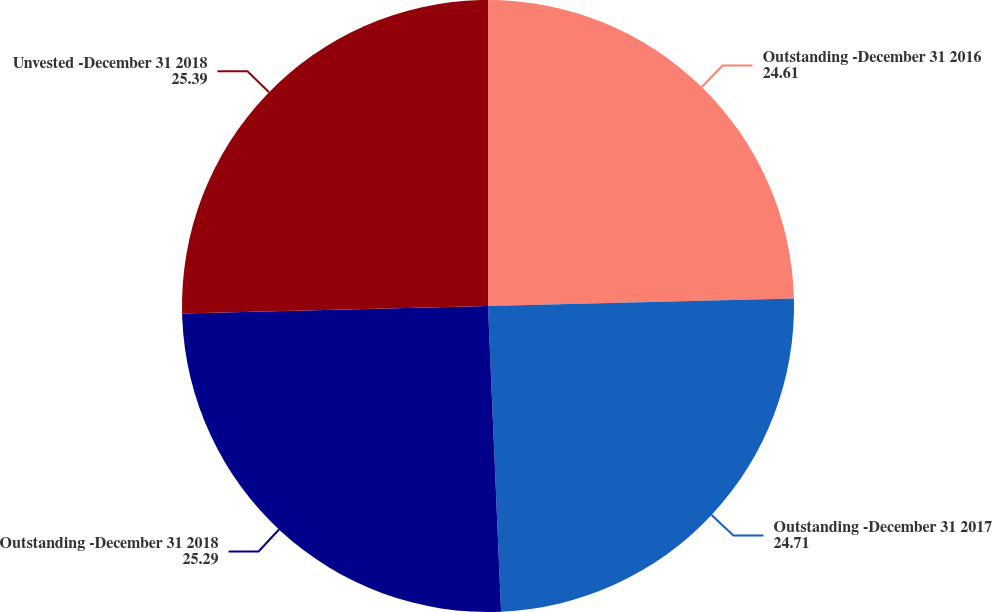Convert chart. <chart><loc_0><loc_0><loc_500><loc_500><pie_chart><fcel>Outstanding -December 31 2016<fcel>Outstanding -December 31 2017<fcel>Outstanding -December 31 2018<fcel>Unvested -December 31 2018<nl><fcel>24.61%<fcel>24.71%<fcel>25.29%<fcel>25.39%<nl></chart> 